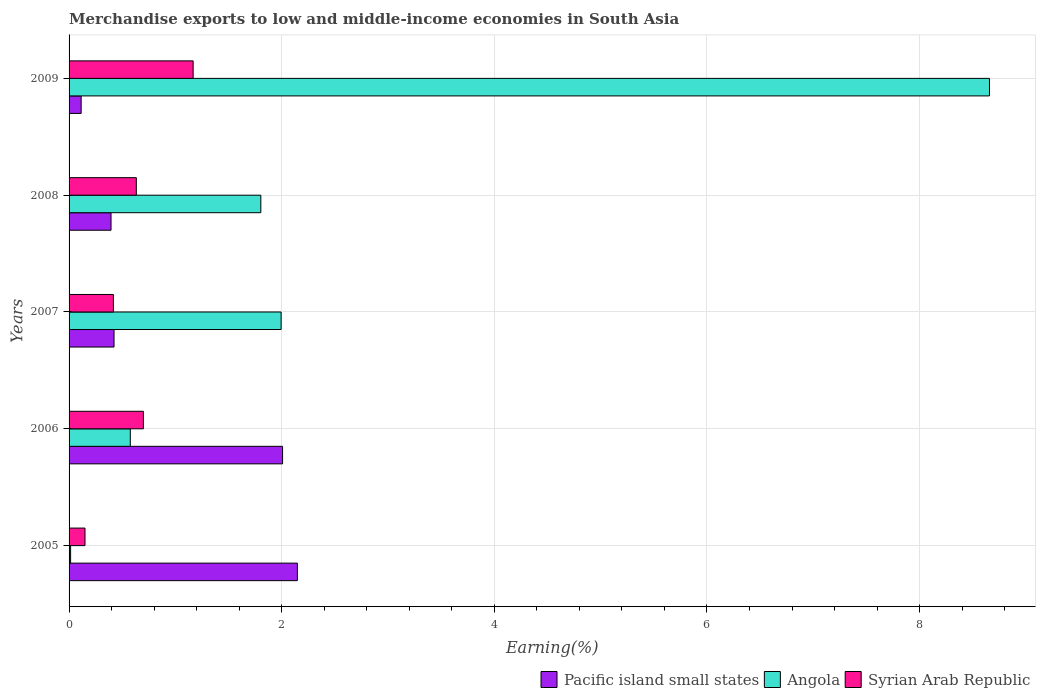How many groups of bars are there?
Keep it short and to the point. 5. What is the label of the 5th group of bars from the top?
Your response must be concise. 2005. In how many cases, is the number of bars for a given year not equal to the number of legend labels?
Offer a very short reply. 0. What is the percentage of amount earned from merchandise exports in Syrian Arab Republic in 2009?
Your answer should be compact. 1.17. Across all years, what is the maximum percentage of amount earned from merchandise exports in Angola?
Provide a succinct answer. 8.66. Across all years, what is the minimum percentage of amount earned from merchandise exports in Syrian Arab Republic?
Give a very brief answer. 0.15. In which year was the percentage of amount earned from merchandise exports in Syrian Arab Republic maximum?
Your answer should be very brief. 2009. In which year was the percentage of amount earned from merchandise exports in Syrian Arab Republic minimum?
Provide a succinct answer. 2005. What is the total percentage of amount earned from merchandise exports in Syrian Arab Republic in the graph?
Your answer should be compact. 3.07. What is the difference between the percentage of amount earned from merchandise exports in Pacific island small states in 2008 and that in 2009?
Your response must be concise. 0.28. What is the difference between the percentage of amount earned from merchandise exports in Angola in 2005 and the percentage of amount earned from merchandise exports in Syrian Arab Republic in 2007?
Provide a succinct answer. -0.4. What is the average percentage of amount earned from merchandise exports in Syrian Arab Republic per year?
Ensure brevity in your answer.  0.61. In the year 2005, what is the difference between the percentage of amount earned from merchandise exports in Syrian Arab Republic and percentage of amount earned from merchandise exports in Angola?
Your answer should be very brief. 0.14. In how many years, is the percentage of amount earned from merchandise exports in Syrian Arab Republic greater than 2 %?
Provide a short and direct response. 0. What is the ratio of the percentage of amount earned from merchandise exports in Angola in 2007 to that in 2009?
Your response must be concise. 0.23. Is the percentage of amount earned from merchandise exports in Pacific island small states in 2005 less than that in 2006?
Give a very brief answer. No. Is the difference between the percentage of amount earned from merchandise exports in Syrian Arab Republic in 2007 and 2008 greater than the difference between the percentage of amount earned from merchandise exports in Angola in 2007 and 2008?
Offer a very short reply. No. What is the difference between the highest and the second highest percentage of amount earned from merchandise exports in Pacific island small states?
Your answer should be very brief. 0.14. What is the difference between the highest and the lowest percentage of amount earned from merchandise exports in Angola?
Keep it short and to the point. 8.64. In how many years, is the percentage of amount earned from merchandise exports in Angola greater than the average percentage of amount earned from merchandise exports in Angola taken over all years?
Make the answer very short. 1. Is the sum of the percentage of amount earned from merchandise exports in Syrian Arab Republic in 2005 and 2007 greater than the maximum percentage of amount earned from merchandise exports in Pacific island small states across all years?
Provide a succinct answer. No. What does the 2nd bar from the top in 2005 represents?
Your answer should be compact. Angola. What does the 1st bar from the bottom in 2007 represents?
Make the answer very short. Pacific island small states. Is it the case that in every year, the sum of the percentage of amount earned from merchandise exports in Pacific island small states and percentage of amount earned from merchandise exports in Angola is greater than the percentage of amount earned from merchandise exports in Syrian Arab Republic?
Offer a very short reply. Yes. How many bars are there?
Offer a very short reply. 15. Are all the bars in the graph horizontal?
Your answer should be compact. Yes. What is the difference between two consecutive major ticks on the X-axis?
Offer a terse response. 2. Are the values on the major ticks of X-axis written in scientific E-notation?
Your answer should be compact. No. Does the graph contain any zero values?
Offer a terse response. No. Does the graph contain grids?
Your answer should be very brief. Yes. Where does the legend appear in the graph?
Provide a short and direct response. Bottom right. How many legend labels are there?
Provide a short and direct response. 3. How are the legend labels stacked?
Provide a short and direct response. Horizontal. What is the title of the graph?
Give a very brief answer. Merchandise exports to low and middle-income economies in South Asia. What is the label or title of the X-axis?
Provide a short and direct response. Earning(%). What is the label or title of the Y-axis?
Make the answer very short. Years. What is the Earning(%) of Pacific island small states in 2005?
Make the answer very short. 2.15. What is the Earning(%) of Angola in 2005?
Give a very brief answer. 0.01. What is the Earning(%) in Syrian Arab Republic in 2005?
Your answer should be compact. 0.15. What is the Earning(%) of Pacific island small states in 2006?
Ensure brevity in your answer.  2.01. What is the Earning(%) in Angola in 2006?
Give a very brief answer. 0.58. What is the Earning(%) of Syrian Arab Republic in 2006?
Give a very brief answer. 0.7. What is the Earning(%) of Pacific island small states in 2007?
Offer a terse response. 0.42. What is the Earning(%) of Angola in 2007?
Your answer should be compact. 1.99. What is the Earning(%) of Syrian Arab Republic in 2007?
Ensure brevity in your answer.  0.42. What is the Earning(%) in Pacific island small states in 2008?
Your response must be concise. 0.39. What is the Earning(%) in Angola in 2008?
Your response must be concise. 1.8. What is the Earning(%) in Syrian Arab Republic in 2008?
Your response must be concise. 0.63. What is the Earning(%) of Pacific island small states in 2009?
Your answer should be very brief. 0.11. What is the Earning(%) of Angola in 2009?
Make the answer very short. 8.66. What is the Earning(%) in Syrian Arab Republic in 2009?
Make the answer very short. 1.17. Across all years, what is the maximum Earning(%) in Pacific island small states?
Keep it short and to the point. 2.15. Across all years, what is the maximum Earning(%) of Angola?
Your response must be concise. 8.66. Across all years, what is the maximum Earning(%) of Syrian Arab Republic?
Make the answer very short. 1.17. Across all years, what is the minimum Earning(%) of Pacific island small states?
Keep it short and to the point. 0.11. Across all years, what is the minimum Earning(%) in Angola?
Provide a short and direct response. 0.01. Across all years, what is the minimum Earning(%) of Syrian Arab Republic?
Offer a terse response. 0.15. What is the total Earning(%) of Pacific island small states in the graph?
Your answer should be compact. 5.09. What is the total Earning(%) in Angola in the graph?
Your answer should be compact. 13.05. What is the total Earning(%) in Syrian Arab Republic in the graph?
Your answer should be very brief. 3.07. What is the difference between the Earning(%) of Pacific island small states in 2005 and that in 2006?
Your response must be concise. 0.14. What is the difference between the Earning(%) of Angola in 2005 and that in 2006?
Ensure brevity in your answer.  -0.56. What is the difference between the Earning(%) of Syrian Arab Republic in 2005 and that in 2006?
Provide a short and direct response. -0.55. What is the difference between the Earning(%) in Pacific island small states in 2005 and that in 2007?
Your answer should be compact. 1.72. What is the difference between the Earning(%) in Angola in 2005 and that in 2007?
Provide a succinct answer. -1.98. What is the difference between the Earning(%) of Syrian Arab Republic in 2005 and that in 2007?
Provide a succinct answer. -0.27. What is the difference between the Earning(%) of Pacific island small states in 2005 and that in 2008?
Give a very brief answer. 1.75. What is the difference between the Earning(%) of Angola in 2005 and that in 2008?
Your answer should be very brief. -1.79. What is the difference between the Earning(%) of Syrian Arab Republic in 2005 and that in 2008?
Your response must be concise. -0.48. What is the difference between the Earning(%) in Pacific island small states in 2005 and that in 2009?
Keep it short and to the point. 2.03. What is the difference between the Earning(%) in Angola in 2005 and that in 2009?
Your answer should be compact. -8.64. What is the difference between the Earning(%) in Syrian Arab Republic in 2005 and that in 2009?
Your response must be concise. -1.02. What is the difference between the Earning(%) in Pacific island small states in 2006 and that in 2007?
Provide a succinct answer. 1.59. What is the difference between the Earning(%) in Angola in 2006 and that in 2007?
Ensure brevity in your answer.  -1.42. What is the difference between the Earning(%) of Syrian Arab Republic in 2006 and that in 2007?
Provide a succinct answer. 0.28. What is the difference between the Earning(%) of Pacific island small states in 2006 and that in 2008?
Your answer should be compact. 1.61. What is the difference between the Earning(%) of Angola in 2006 and that in 2008?
Ensure brevity in your answer.  -1.23. What is the difference between the Earning(%) in Syrian Arab Republic in 2006 and that in 2008?
Keep it short and to the point. 0.07. What is the difference between the Earning(%) in Pacific island small states in 2006 and that in 2009?
Your response must be concise. 1.89. What is the difference between the Earning(%) in Angola in 2006 and that in 2009?
Keep it short and to the point. -8.08. What is the difference between the Earning(%) of Syrian Arab Republic in 2006 and that in 2009?
Keep it short and to the point. -0.47. What is the difference between the Earning(%) in Pacific island small states in 2007 and that in 2008?
Offer a terse response. 0.03. What is the difference between the Earning(%) in Angola in 2007 and that in 2008?
Offer a very short reply. 0.19. What is the difference between the Earning(%) in Syrian Arab Republic in 2007 and that in 2008?
Make the answer very short. -0.22. What is the difference between the Earning(%) in Pacific island small states in 2007 and that in 2009?
Offer a very short reply. 0.31. What is the difference between the Earning(%) of Angola in 2007 and that in 2009?
Offer a terse response. -6.66. What is the difference between the Earning(%) of Syrian Arab Republic in 2007 and that in 2009?
Provide a succinct answer. -0.75. What is the difference between the Earning(%) of Pacific island small states in 2008 and that in 2009?
Your answer should be very brief. 0.28. What is the difference between the Earning(%) of Angola in 2008 and that in 2009?
Keep it short and to the point. -6.85. What is the difference between the Earning(%) of Syrian Arab Republic in 2008 and that in 2009?
Your answer should be very brief. -0.53. What is the difference between the Earning(%) in Pacific island small states in 2005 and the Earning(%) in Angola in 2006?
Give a very brief answer. 1.57. What is the difference between the Earning(%) of Pacific island small states in 2005 and the Earning(%) of Syrian Arab Republic in 2006?
Your response must be concise. 1.45. What is the difference between the Earning(%) in Angola in 2005 and the Earning(%) in Syrian Arab Republic in 2006?
Ensure brevity in your answer.  -0.68. What is the difference between the Earning(%) of Pacific island small states in 2005 and the Earning(%) of Angola in 2007?
Your answer should be compact. 0.15. What is the difference between the Earning(%) of Pacific island small states in 2005 and the Earning(%) of Syrian Arab Republic in 2007?
Keep it short and to the point. 1.73. What is the difference between the Earning(%) of Angola in 2005 and the Earning(%) of Syrian Arab Republic in 2007?
Your response must be concise. -0.4. What is the difference between the Earning(%) of Pacific island small states in 2005 and the Earning(%) of Angola in 2008?
Your answer should be compact. 0.34. What is the difference between the Earning(%) in Pacific island small states in 2005 and the Earning(%) in Syrian Arab Republic in 2008?
Ensure brevity in your answer.  1.51. What is the difference between the Earning(%) of Angola in 2005 and the Earning(%) of Syrian Arab Republic in 2008?
Provide a succinct answer. -0.62. What is the difference between the Earning(%) in Pacific island small states in 2005 and the Earning(%) in Angola in 2009?
Ensure brevity in your answer.  -6.51. What is the difference between the Earning(%) of Pacific island small states in 2005 and the Earning(%) of Syrian Arab Republic in 2009?
Your answer should be compact. 0.98. What is the difference between the Earning(%) of Angola in 2005 and the Earning(%) of Syrian Arab Republic in 2009?
Your answer should be compact. -1.15. What is the difference between the Earning(%) of Pacific island small states in 2006 and the Earning(%) of Angola in 2007?
Provide a succinct answer. 0.01. What is the difference between the Earning(%) of Pacific island small states in 2006 and the Earning(%) of Syrian Arab Republic in 2007?
Offer a very short reply. 1.59. What is the difference between the Earning(%) of Angola in 2006 and the Earning(%) of Syrian Arab Republic in 2007?
Your answer should be compact. 0.16. What is the difference between the Earning(%) of Pacific island small states in 2006 and the Earning(%) of Angola in 2008?
Give a very brief answer. 0.2. What is the difference between the Earning(%) in Pacific island small states in 2006 and the Earning(%) in Syrian Arab Republic in 2008?
Offer a terse response. 1.38. What is the difference between the Earning(%) in Angola in 2006 and the Earning(%) in Syrian Arab Republic in 2008?
Your answer should be compact. -0.06. What is the difference between the Earning(%) in Pacific island small states in 2006 and the Earning(%) in Angola in 2009?
Provide a succinct answer. -6.65. What is the difference between the Earning(%) in Pacific island small states in 2006 and the Earning(%) in Syrian Arab Republic in 2009?
Provide a succinct answer. 0.84. What is the difference between the Earning(%) of Angola in 2006 and the Earning(%) of Syrian Arab Republic in 2009?
Your answer should be very brief. -0.59. What is the difference between the Earning(%) of Pacific island small states in 2007 and the Earning(%) of Angola in 2008?
Offer a terse response. -1.38. What is the difference between the Earning(%) of Pacific island small states in 2007 and the Earning(%) of Syrian Arab Republic in 2008?
Provide a succinct answer. -0.21. What is the difference between the Earning(%) in Angola in 2007 and the Earning(%) in Syrian Arab Republic in 2008?
Offer a terse response. 1.36. What is the difference between the Earning(%) of Pacific island small states in 2007 and the Earning(%) of Angola in 2009?
Keep it short and to the point. -8.23. What is the difference between the Earning(%) of Pacific island small states in 2007 and the Earning(%) of Syrian Arab Republic in 2009?
Give a very brief answer. -0.74. What is the difference between the Earning(%) of Angola in 2007 and the Earning(%) of Syrian Arab Republic in 2009?
Your answer should be very brief. 0.83. What is the difference between the Earning(%) of Pacific island small states in 2008 and the Earning(%) of Angola in 2009?
Your answer should be compact. -8.26. What is the difference between the Earning(%) in Pacific island small states in 2008 and the Earning(%) in Syrian Arab Republic in 2009?
Offer a terse response. -0.77. What is the difference between the Earning(%) of Angola in 2008 and the Earning(%) of Syrian Arab Republic in 2009?
Your answer should be compact. 0.64. What is the average Earning(%) in Pacific island small states per year?
Give a very brief answer. 1.02. What is the average Earning(%) in Angola per year?
Ensure brevity in your answer.  2.61. What is the average Earning(%) in Syrian Arab Republic per year?
Provide a short and direct response. 0.61. In the year 2005, what is the difference between the Earning(%) in Pacific island small states and Earning(%) in Angola?
Your response must be concise. 2.13. In the year 2005, what is the difference between the Earning(%) in Pacific island small states and Earning(%) in Syrian Arab Republic?
Offer a very short reply. 2. In the year 2005, what is the difference between the Earning(%) in Angola and Earning(%) in Syrian Arab Republic?
Ensure brevity in your answer.  -0.14. In the year 2006, what is the difference between the Earning(%) of Pacific island small states and Earning(%) of Angola?
Keep it short and to the point. 1.43. In the year 2006, what is the difference between the Earning(%) of Pacific island small states and Earning(%) of Syrian Arab Republic?
Your answer should be very brief. 1.31. In the year 2006, what is the difference between the Earning(%) in Angola and Earning(%) in Syrian Arab Republic?
Make the answer very short. -0.12. In the year 2007, what is the difference between the Earning(%) in Pacific island small states and Earning(%) in Angola?
Offer a very short reply. -1.57. In the year 2007, what is the difference between the Earning(%) of Pacific island small states and Earning(%) of Syrian Arab Republic?
Give a very brief answer. 0.01. In the year 2007, what is the difference between the Earning(%) in Angola and Earning(%) in Syrian Arab Republic?
Offer a very short reply. 1.58. In the year 2008, what is the difference between the Earning(%) in Pacific island small states and Earning(%) in Angola?
Provide a succinct answer. -1.41. In the year 2008, what is the difference between the Earning(%) in Pacific island small states and Earning(%) in Syrian Arab Republic?
Keep it short and to the point. -0.24. In the year 2008, what is the difference between the Earning(%) of Angola and Earning(%) of Syrian Arab Republic?
Your answer should be very brief. 1.17. In the year 2009, what is the difference between the Earning(%) of Pacific island small states and Earning(%) of Angola?
Provide a succinct answer. -8.54. In the year 2009, what is the difference between the Earning(%) in Pacific island small states and Earning(%) in Syrian Arab Republic?
Your answer should be compact. -1.05. In the year 2009, what is the difference between the Earning(%) in Angola and Earning(%) in Syrian Arab Republic?
Your answer should be very brief. 7.49. What is the ratio of the Earning(%) of Pacific island small states in 2005 to that in 2006?
Give a very brief answer. 1.07. What is the ratio of the Earning(%) of Angola in 2005 to that in 2006?
Provide a succinct answer. 0.03. What is the ratio of the Earning(%) of Syrian Arab Republic in 2005 to that in 2006?
Make the answer very short. 0.21. What is the ratio of the Earning(%) of Pacific island small states in 2005 to that in 2007?
Your answer should be compact. 5.08. What is the ratio of the Earning(%) in Angola in 2005 to that in 2007?
Your answer should be compact. 0.01. What is the ratio of the Earning(%) of Syrian Arab Republic in 2005 to that in 2007?
Give a very brief answer. 0.36. What is the ratio of the Earning(%) in Pacific island small states in 2005 to that in 2008?
Your answer should be compact. 5.44. What is the ratio of the Earning(%) in Angola in 2005 to that in 2008?
Give a very brief answer. 0.01. What is the ratio of the Earning(%) of Syrian Arab Republic in 2005 to that in 2008?
Give a very brief answer. 0.24. What is the ratio of the Earning(%) of Pacific island small states in 2005 to that in 2009?
Ensure brevity in your answer.  18.89. What is the ratio of the Earning(%) of Angola in 2005 to that in 2009?
Provide a short and direct response. 0. What is the ratio of the Earning(%) in Syrian Arab Republic in 2005 to that in 2009?
Provide a succinct answer. 0.13. What is the ratio of the Earning(%) of Pacific island small states in 2006 to that in 2007?
Give a very brief answer. 4.75. What is the ratio of the Earning(%) in Angola in 2006 to that in 2007?
Provide a succinct answer. 0.29. What is the ratio of the Earning(%) in Syrian Arab Republic in 2006 to that in 2007?
Ensure brevity in your answer.  1.68. What is the ratio of the Earning(%) in Pacific island small states in 2006 to that in 2008?
Your answer should be very brief. 5.09. What is the ratio of the Earning(%) of Angola in 2006 to that in 2008?
Provide a succinct answer. 0.32. What is the ratio of the Earning(%) of Syrian Arab Republic in 2006 to that in 2008?
Offer a very short reply. 1.1. What is the ratio of the Earning(%) of Pacific island small states in 2006 to that in 2009?
Keep it short and to the point. 17.67. What is the ratio of the Earning(%) of Angola in 2006 to that in 2009?
Keep it short and to the point. 0.07. What is the ratio of the Earning(%) in Syrian Arab Republic in 2006 to that in 2009?
Your response must be concise. 0.6. What is the ratio of the Earning(%) in Pacific island small states in 2007 to that in 2008?
Offer a terse response. 1.07. What is the ratio of the Earning(%) of Angola in 2007 to that in 2008?
Provide a succinct answer. 1.11. What is the ratio of the Earning(%) of Syrian Arab Republic in 2007 to that in 2008?
Your answer should be compact. 0.66. What is the ratio of the Earning(%) in Pacific island small states in 2007 to that in 2009?
Your answer should be very brief. 3.72. What is the ratio of the Earning(%) of Angola in 2007 to that in 2009?
Your answer should be very brief. 0.23. What is the ratio of the Earning(%) of Syrian Arab Republic in 2007 to that in 2009?
Keep it short and to the point. 0.36. What is the ratio of the Earning(%) of Pacific island small states in 2008 to that in 2009?
Provide a succinct answer. 3.47. What is the ratio of the Earning(%) of Angola in 2008 to that in 2009?
Give a very brief answer. 0.21. What is the ratio of the Earning(%) of Syrian Arab Republic in 2008 to that in 2009?
Give a very brief answer. 0.54. What is the difference between the highest and the second highest Earning(%) in Pacific island small states?
Your answer should be very brief. 0.14. What is the difference between the highest and the second highest Earning(%) of Angola?
Offer a terse response. 6.66. What is the difference between the highest and the second highest Earning(%) of Syrian Arab Republic?
Give a very brief answer. 0.47. What is the difference between the highest and the lowest Earning(%) of Pacific island small states?
Your response must be concise. 2.03. What is the difference between the highest and the lowest Earning(%) of Angola?
Make the answer very short. 8.64. What is the difference between the highest and the lowest Earning(%) in Syrian Arab Republic?
Give a very brief answer. 1.02. 